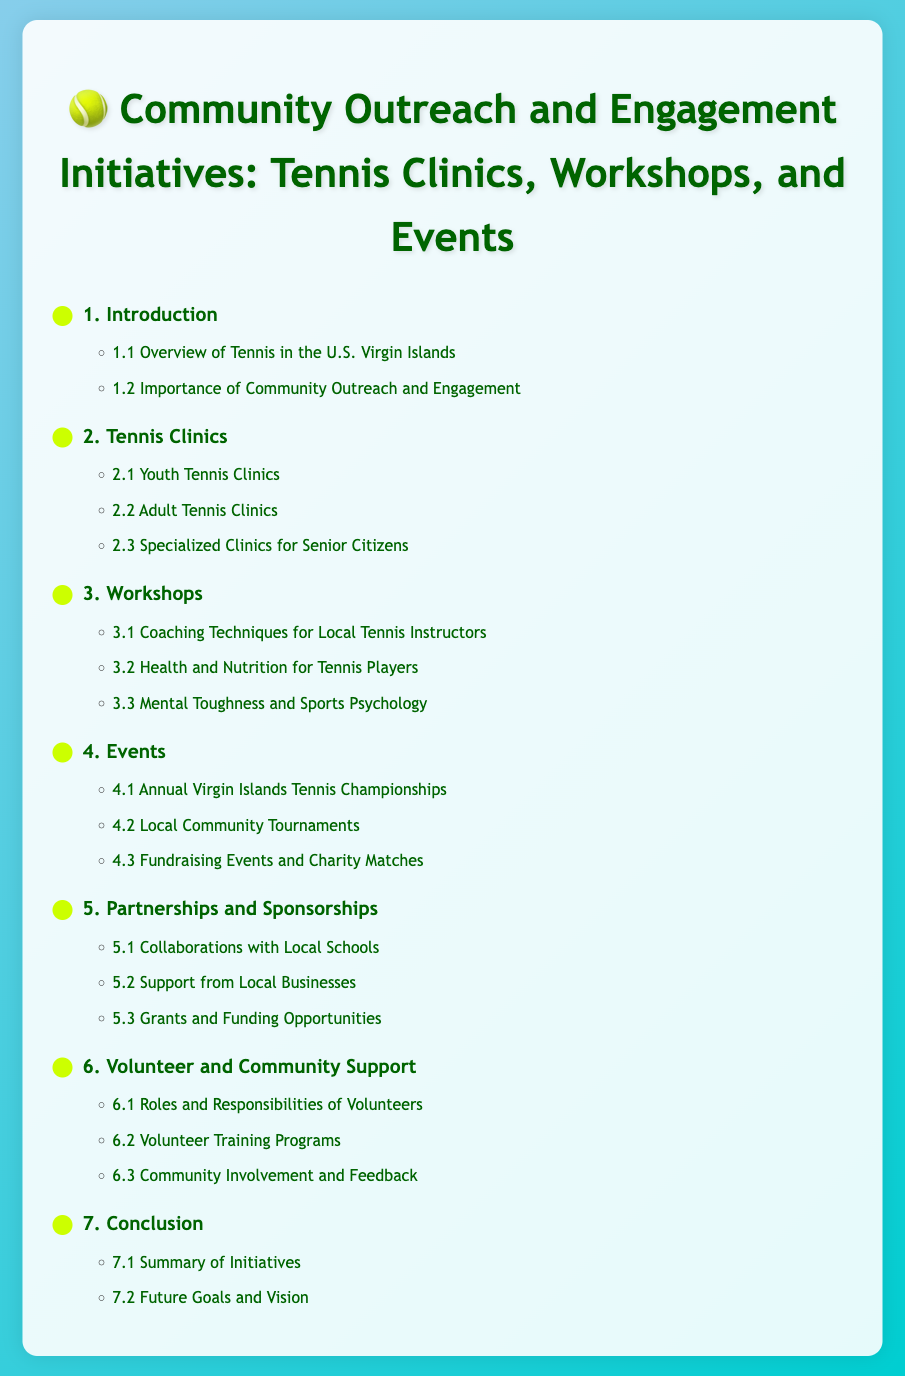What is the first section of the document? The first section is the introductory part that describes the overall context of the document.
Answer: Introduction How many types of tennis clinics are mentioned? There are three types of tennis clinics listed in the document.
Answer: Three What are the topics covered in the workshops? The workshops address coaching techniques, health and nutrition, and mental toughness.
Answer: Coaching Techniques, Health and Nutrition, Mental Toughness What is the last subsection of the events section? This subsection focuses on fundraising and charity events in the community.
Answer: Fundraising Events and Charity Matches What section discusses partnerships? This section details collaborations and support offered by various entities.
Answer: Partnerships and Sponsorships How many roles are specified for volunteers? The document outlines three specific roles for volunteers.
Answer: Three 